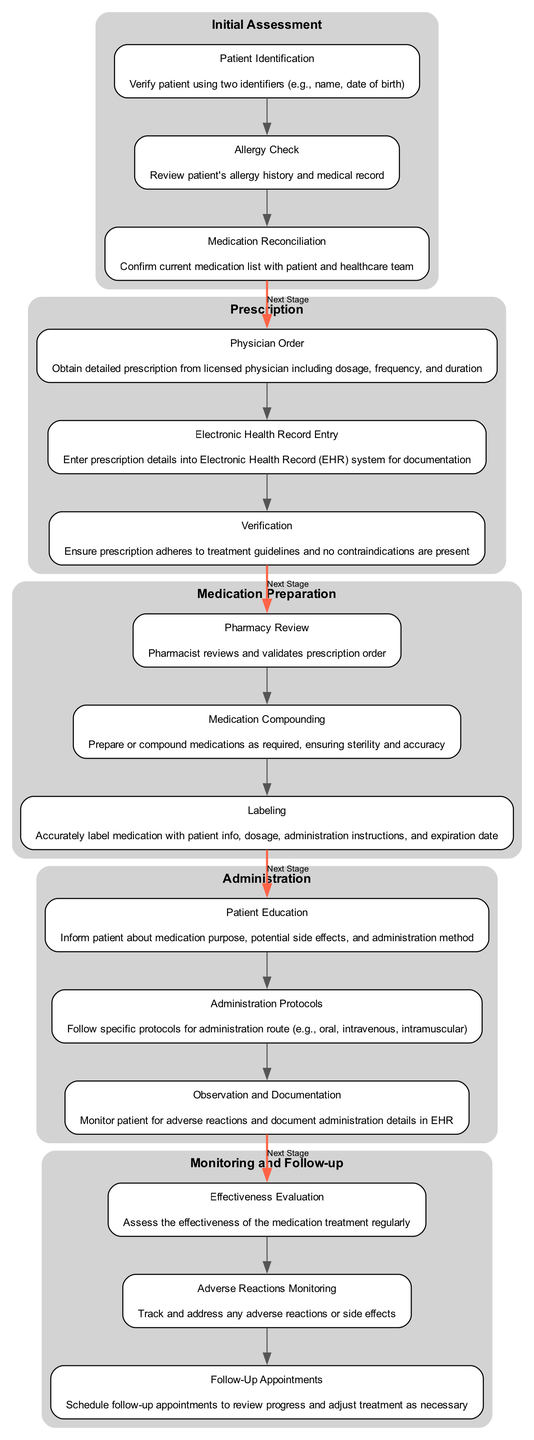What is the first step in the Medication Administration Pathway? The first step in the pathway is "Patient Identification," which verifies the patient's identity using two identifiers.
Answer: Patient Identification How many steps are in the Administration stage? The Administration stage contains three steps: Patient Education, Administration Protocols, and Observation and Documentation.
Answer: 3 What immediately follows Medication Preparation? The stage that follows Medication Preparation is Administration. This can be identified by looking at the edges that connect these two stages in the diagram.
Answer: Administration What should be done during the Allergy Check? During the Allergy Check, the patient's allergy history and medical record should be reviewed to ensure safety before medication administration.
Answer: Review patient's allergy history and medical record How many total stages are there in the Medication Administration Pathway? The diagram outlines five distinct stages: Initial Assessment, Prescription, Medication Preparation, Administration, and Monitoring and Follow-up.
Answer: 5 What is the last step in the Monitoring and Follow-up stage? The last step in the Monitoring and Follow-up stage is "Follow-Up Appointments," which involves scheduling appointments to review progress.
Answer: Follow-Up Appointments Which step involves ensuring the prescription adheres to treatment guidelines? The step responsible for this is "Verification," which checks that the prescription is appropriate and has no contraindications.
Answer: Verification What is the purpose of the Observation and Documentation step? The purpose of this step is to monitor the patient for adverse reactions and to document the details of medication administration in the Electronic Health Record.
Answer: Monitor patient for adverse reactions and document administration details How does the Medication Preparation stage ensure sterility? The stage ensures sterility through the "Medication Compounding" step, where medications are prepared in a sterile environment and accurately to avoid contamination.
Answer: Ensure sterility through compounding 